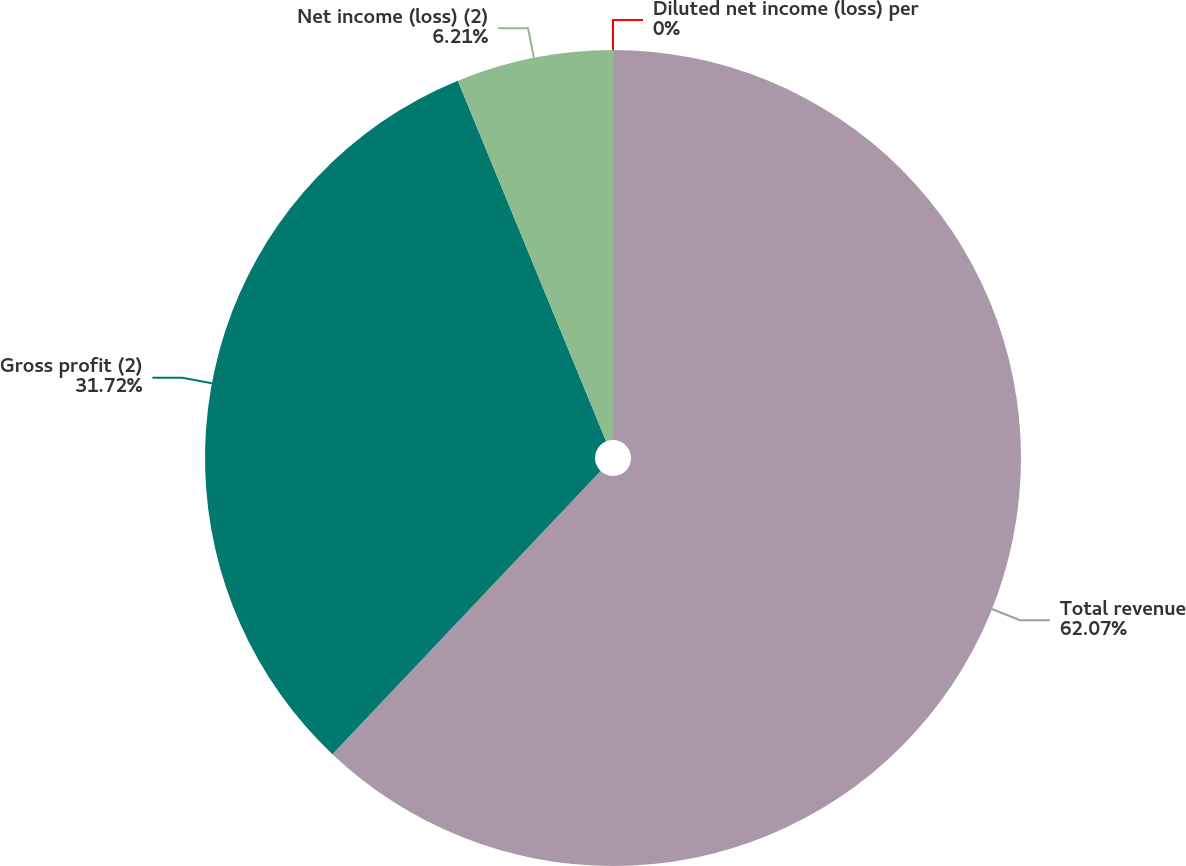Convert chart. <chart><loc_0><loc_0><loc_500><loc_500><pie_chart><fcel>Total revenue<fcel>Gross profit (2)<fcel>Net income (loss) (2)<fcel>Diluted net income (loss) per<nl><fcel>62.07%<fcel>31.72%<fcel>6.21%<fcel>0.0%<nl></chart> 